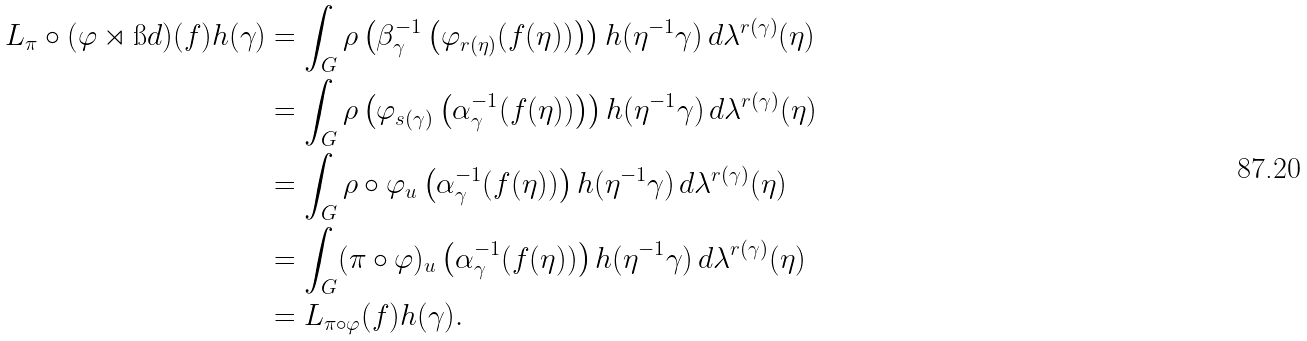<formula> <loc_0><loc_0><loc_500><loc_500>L _ { \pi } \circ ( \varphi \rtimes \i d ) ( f ) h ( \gamma ) & = \int _ { G } \rho \left ( \beta _ { \gamma } ^ { - 1 } \left ( \varphi _ { r ( \eta ) } ( f ( \eta ) ) \right ) \right ) h ( \eta ^ { - 1 } \gamma ) \, d \lambda ^ { r ( \gamma ) } ( \eta ) \\ & = \int _ { G } \rho \left ( \varphi _ { s ( \gamma ) } \left ( \alpha _ { \gamma } ^ { - 1 } ( f ( \eta ) ) \right ) \right ) h ( \eta ^ { - 1 } \gamma ) \, d \lambda ^ { r ( \gamma ) } ( \eta ) \\ & = \int _ { G } \rho \circ \varphi _ { u } \left ( \alpha _ { \gamma } ^ { - 1 } ( f ( \eta ) ) \right ) h ( \eta ^ { - 1 } \gamma ) \, d \lambda ^ { r ( \gamma ) } ( \eta ) \\ & = \int _ { G } ( \pi \circ \varphi ) _ { u } \left ( \alpha _ { \gamma } ^ { - 1 } ( f ( \eta ) ) \right ) h ( \eta ^ { - 1 } \gamma ) \, d \lambda ^ { r ( \gamma ) } ( \eta ) \\ & = L _ { \pi \circ \varphi } ( f ) h ( \gamma ) .</formula> 